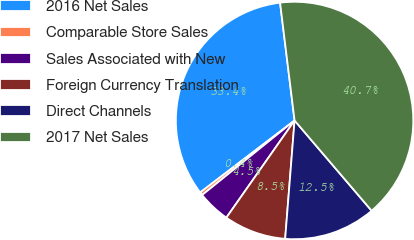Convert chart. <chart><loc_0><loc_0><loc_500><loc_500><pie_chart><fcel>2016 Net Sales<fcel>Comparable Store Sales<fcel>Sales Associated with New<fcel>Foreign Currency Translation<fcel>Direct Channels<fcel>2017 Net Sales<nl><fcel>33.42%<fcel>0.43%<fcel>4.46%<fcel>8.48%<fcel>12.51%<fcel>40.7%<nl></chart> 